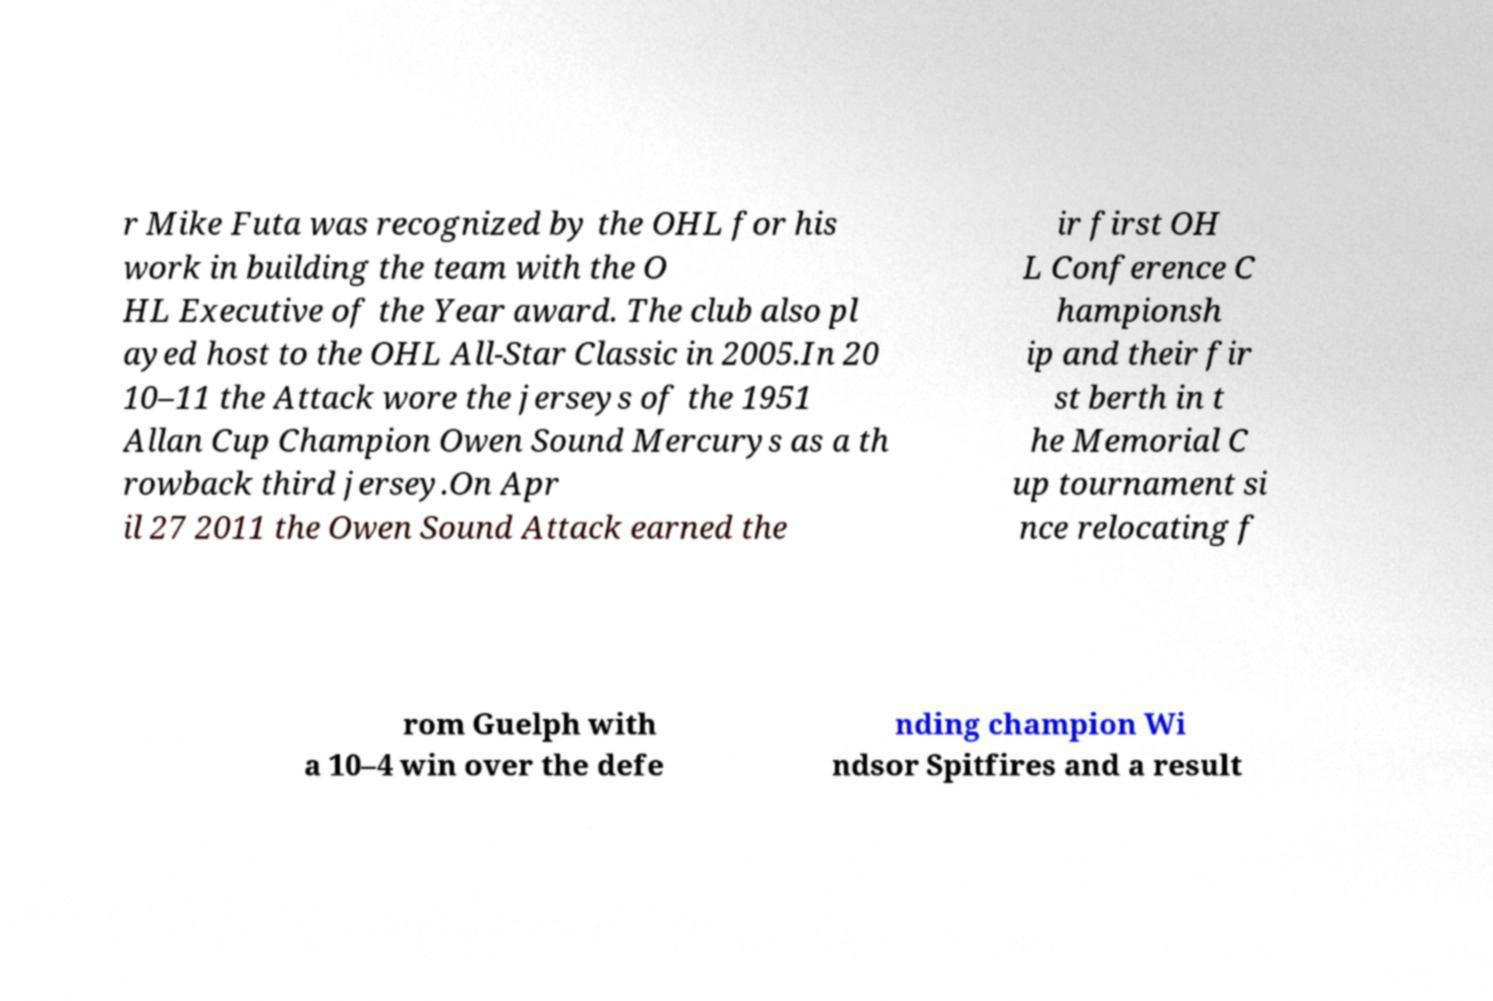Could you extract and type out the text from this image? r Mike Futa was recognized by the OHL for his work in building the team with the O HL Executive of the Year award. The club also pl ayed host to the OHL All-Star Classic in 2005.In 20 10–11 the Attack wore the jerseys of the 1951 Allan Cup Champion Owen Sound Mercurys as a th rowback third jersey.On Apr il 27 2011 the Owen Sound Attack earned the ir first OH L Conference C hampionsh ip and their fir st berth in t he Memorial C up tournament si nce relocating f rom Guelph with a 10–4 win over the defe nding champion Wi ndsor Spitfires and a result 